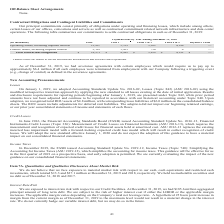From Zix Corporation's financial document, What was the total payments due by year ending december 31, 2020 for operating leases, including imputed interest and for Finance leases, including imputed interest, respectively? The document shows two values: 12,807 and 2,165 (in thousands). From the document: "Operating leases, including imputed interest 12,807 3,519 5,102 4,186 — Finance leases, including imputed interest (1) 2,165 1,423 736 6 —..." Also, What are the components that are related to finance leases? The document shows two values: servers and network infrastructure and data center operations.. From the document: "(1) Finance leases are related to servers and network infrastructure and our data center operations. tual commitment related network infrastructure an..." Also, How much would the company have to pay up to as defined in the severance agreements as of December 31, 2019 following a triggering event in the company? approximately $6.4 million. The document states: "ain employees which would require us to pay up to approximately $6.4 million if all such employees were terminated from employment with our Company fo..." Also, can you calculate: What is the payments due for Operating leases, including imputed interest from years 1 to 3? Based on the calculation: 3,519+5,102, the result is 8621 (in thousands). This is based on the information: "g leases, including imputed interest 12,807 3,519 5,102 4,186 — erating leases, including imputed interest 12,807 3,519 5,102 4,186 —..." The key data points involved are: 3,519, 5,102. Also, can you calculate: What is the percentage constitution of total operating leases among the total contractual obligations? Based on the calculation: 12,807/14,972, the result is 85.54 (percentage). This is based on the information: "Total contractual obligations $ 14,972 $ 4,942 $ 5,838 $ 4,192 $ — Operating leases, including imputed interest 12,807 3,519 5,102 4,186 —..." The key data points involved are: 12,807, 14,972. Also, can you calculate: How much more in total contractual obligations does the company expect to spend in Year 1 than Years 4 & 5? Based on the calculation:  4,942-4,192, the result is 750 (in thousands). This is based on the information: "Total contractual obligations $ 14,972 $ 4,942 $ 5,838 $ 4,192 $ — ontractual obligations $ 14,972 $ 4,942 $ 5,838 $ 4,192 $ —..." The key data points involved are: 4,192, 4,942. 